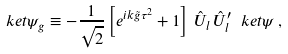<formula> <loc_0><loc_0><loc_500><loc_500>\ k e t { \psi _ { g } } \equiv - \frac { 1 } { \sqrt { 2 } } \left [ e ^ { i k \tilde { g } \tau ^ { 2 } } + 1 \right ] \, \hat { U } _ { l } \, \hat { U } ^ { \prime } _ { l } \ k e t { \psi } \, ,</formula> 